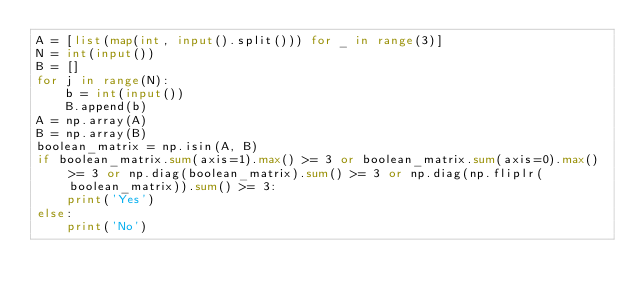Convert code to text. <code><loc_0><loc_0><loc_500><loc_500><_Python_>A = [list(map(int, input().split())) for _ in range(3)]
N = int(input())
B = []
for j in range(N):
    b = int(input())
    B.append(b)
A = np.array(A)
B = np.array(B)
boolean_matrix = np.isin(A, B)
if boolean_matrix.sum(axis=1).max() >= 3 or boolean_matrix.sum(axis=0).max() >= 3 or np.diag(boolean_matrix).sum() >= 3 or np.diag(np.fliplr(boolean_matrix)).sum() >= 3:
    print('Yes')
else:
    print('No')</code> 